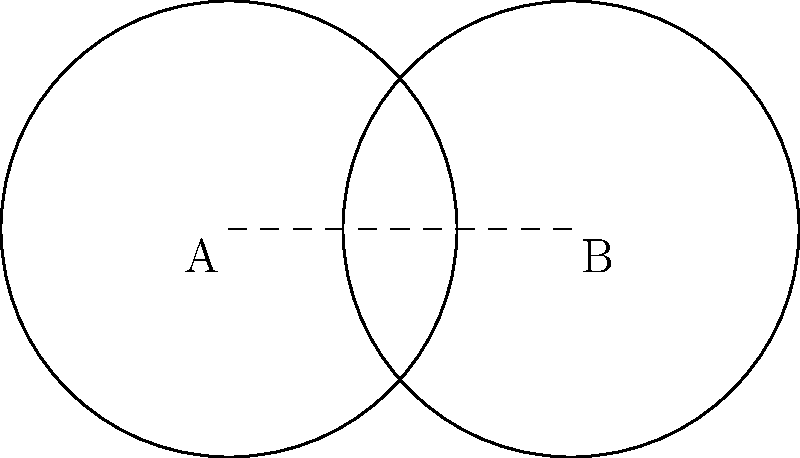In your shared workspace with the retired teacher, you both have circular writing desks with a radius of 2 meters. The centers of the desks are 3 meters apart. Calculate the area of the overlapping region where you often collaborate on memoir feedback. Round your answer to two decimal places. Let's approach this step-by-step:

1) First, we need to recognize that this is a problem involving the area of intersection of two circles.

2) The formula for the area of intersection is:

   $$A = 2r^2 \arccos(\frac{d}{2r}) - d\sqrt{r^2 - \frac{d^2}{4}}$$

   where $r$ is the radius of each circle and $d$ is the distance between their centers.

3) We're given:
   $r = 2$ meters
   $d = 3$ meters

4) Let's substitute these values into our formula:

   $$A = 2(2^2) \arccos(\frac{3}{2(2)}) - 3\sqrt{2^2 - \frac{3^2}{4}}$$

5) Simplify:
   $$A = 8 \arccos(\frac{3}{4}) - 3\sqrt{4 - \frac{9}{4}}$$
   $$A = 8 \arccos(\frac{3}{4}) - 3\sqrt{\frac{7}{4}}$$

6) Calculate:
   $$A \approx 8(0.7227) - 3(1.3229)$$
   $$A \approx 5.7816 - 3.9687$$
   $$A \approx 1.8129$$

7) Rounding to two decimal places:
   $$A \approx 1.81 \text{ square meters}$$
Answer: 1.81 square meters 